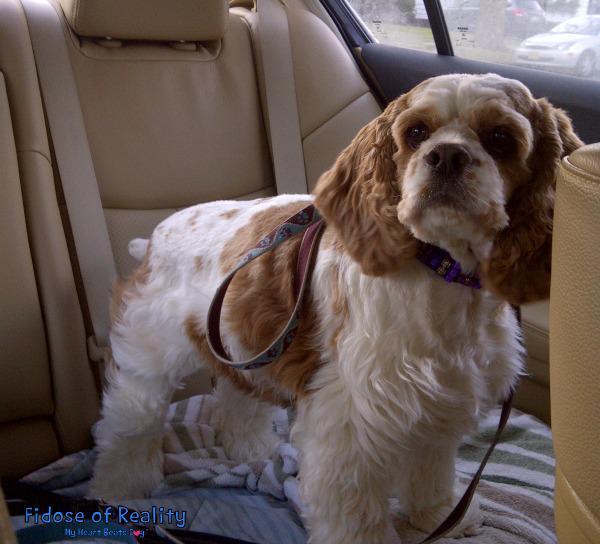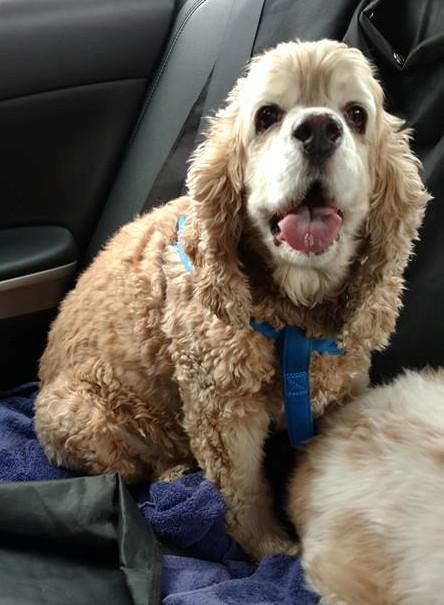The first image is the image on the left, the second image is the image on the right. For the images displayed, is the sentence "Human hands can be seen holding the dog's ear in one image." factually correct? Answer yes or no. No. 